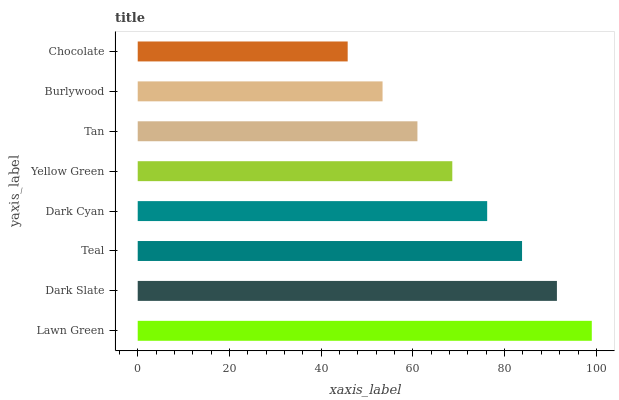Is Chocolate the minimum?
Answer yes or no. Yes. Is Lawn Green the maximum?
Answer yes or no. Yes. Is Dark Slate the minimum?
Answer yes or no. No. Is Dark Slate the maximum?
Answer yes or no. No. Is Lawn Green greater than Dark Slate?
Answer yes or no. Yes. Is Dark Slate less than Lawn Green?
Answer yes or no. Yes. Is Dark Slate greater than Lawn Green?
Answer yes or no. No. Is Lawn Green less than Dark Slate?
Answer yes or no. No. Is Dark Cyan the high median?
Answer yes or no. Yes. Is Yellow Green the low median?
Answer yes or no. Yes. Is Teal the high median?
Answer yes or no. No. Is Lawn Green the low median?
Answer yes or no. No. 